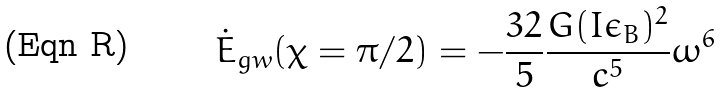Convert formula to latex. <formula><loc_0><loc_0><loc_500><loc_500>\dot { E } _ { g w } ( \chi = \pi / 2 ) = - \frac { 3 2 } { 5 } \frac { G ( I \epsilon _ { B } ) ^ { 2 } } { c ^ { 5 } } \omega ^ { 6 }</formula> 